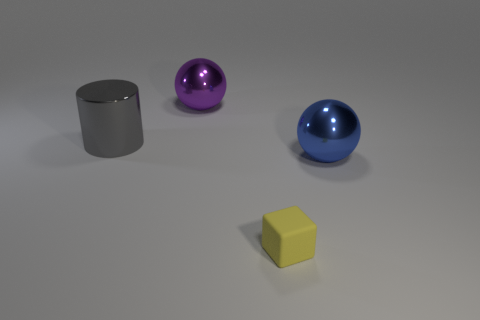Is there anything else that has the same size as the matte thing?
Make the answer very short. No. Are there fewer large shiny spheres left of the large gray shiny thing than cylinders?
Your answer should be compact. Yes. How many purple things are there?
Provide a short and direct response. 1. There is a large metallic thing on the left side of the big sphere that is behind the large blue object; what shape is it?
Offer a terse response. Cylinder. There is a purple ball; how many gray shiny objects are left of it?
Your response must be concise. 1. Are the blue object and the cube in front of the large cylinder made of the same material?
Your answer should be very brief. No. Are there any other purple shiny things that have the same size as the purple metal thing?
Give a very brief answer. No. Are there an equal number of big metal spheres that are behind the purple sphere and small yellow metallic cubes?
Offer a very short reply. Yes. What is the size of the matte object?
Ensure brevity in your answer.  Small. What number of blue metallic spheres are left of the object that is to the right of the tiny yellow object?
Your answer should be very brief. 0. 